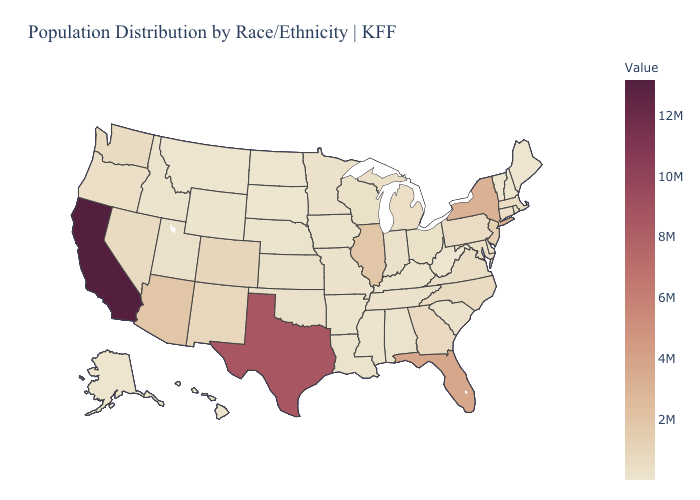Which states have the lowest value in the USA?
Answer briefly. Vermont. Among the states that border Texas , which have the lowest value?
Quick response, please. Louisiana. Is the legend a continuous bar?
Give a very brief answer. Yes. Among the states that border Idaho , does Utah have the lowest value?
Short answer required. No. 